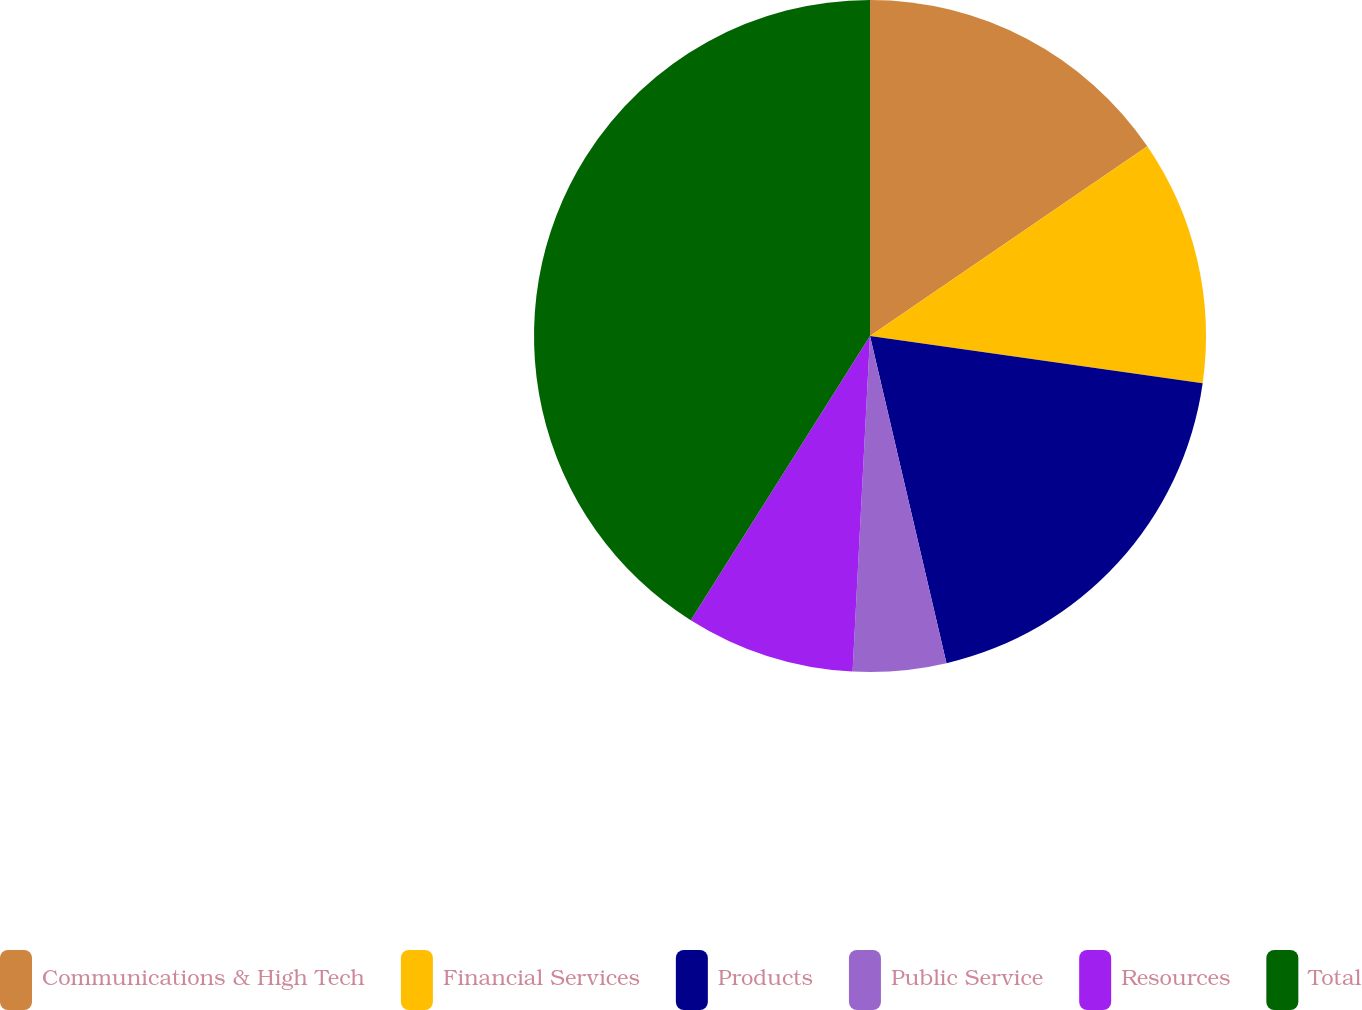<chart> <loc_0><loc_0><loc_500><loc_500><pie_chart><fcel>Communications & High Tech<fcel>Financial Services<fcel>Products<fcel>Public Service<fcel>Resources<fcel>Total<nl><fcel>15.45%<fcel>11.79%<fcel>19.1%<fcel>4.48%<fcel>8.13%<fcel>41.04%<nl></chart> 